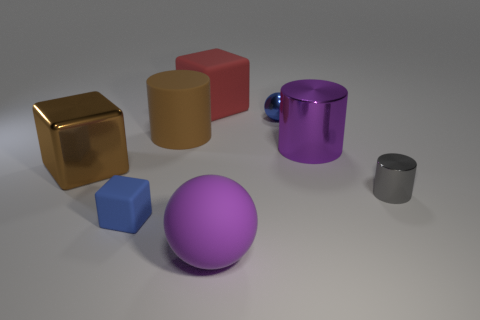Subtract all blue balls. How many balls are left? 1 Subtract all blue cubes. How many cubes are left? 2 Subtract 2 blocks. How many blocks are left? 1 Subtract all blue cubes. How many brown cylinders are left? 1 Add 4 small purple objects. How many small purple objects exist? 4 Add 2 big brown things. How many objects exist? 10 Subtract 0 brown balls. How many objects are left? 8 Subtract all spheres. How many objects are left? 6 Subtract all cyan cylinders. Subtract all blue blocks. How many cylinders are left? 3 Subtract all tiny purple matte cylinders. Subtract all large purple rubber spheres. How many objects are left? 7 